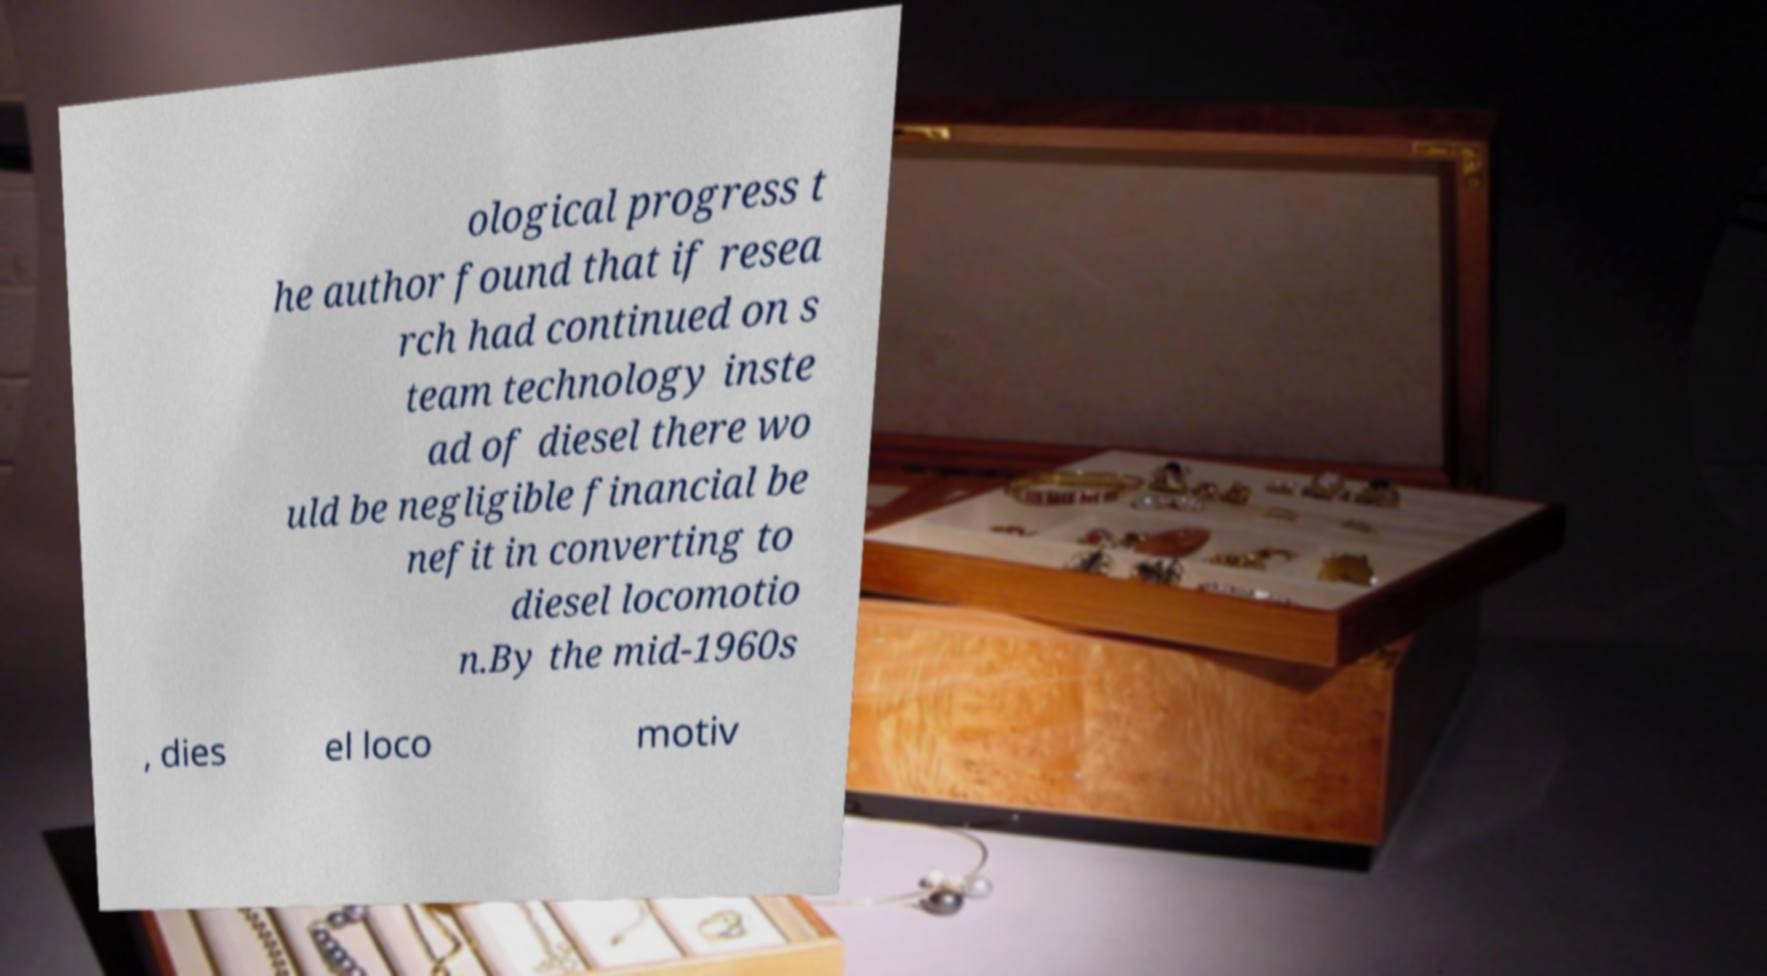There's text embedded in this image that I need extracted. Can you transcribe it verbatim? ological progress t he author found that if resea rch had continued on s team technology inste ad of diesel there wo uld be negligible financial be nefit in converting to diesel locomotio n.By the mid-1960s , dies el loco motiv 